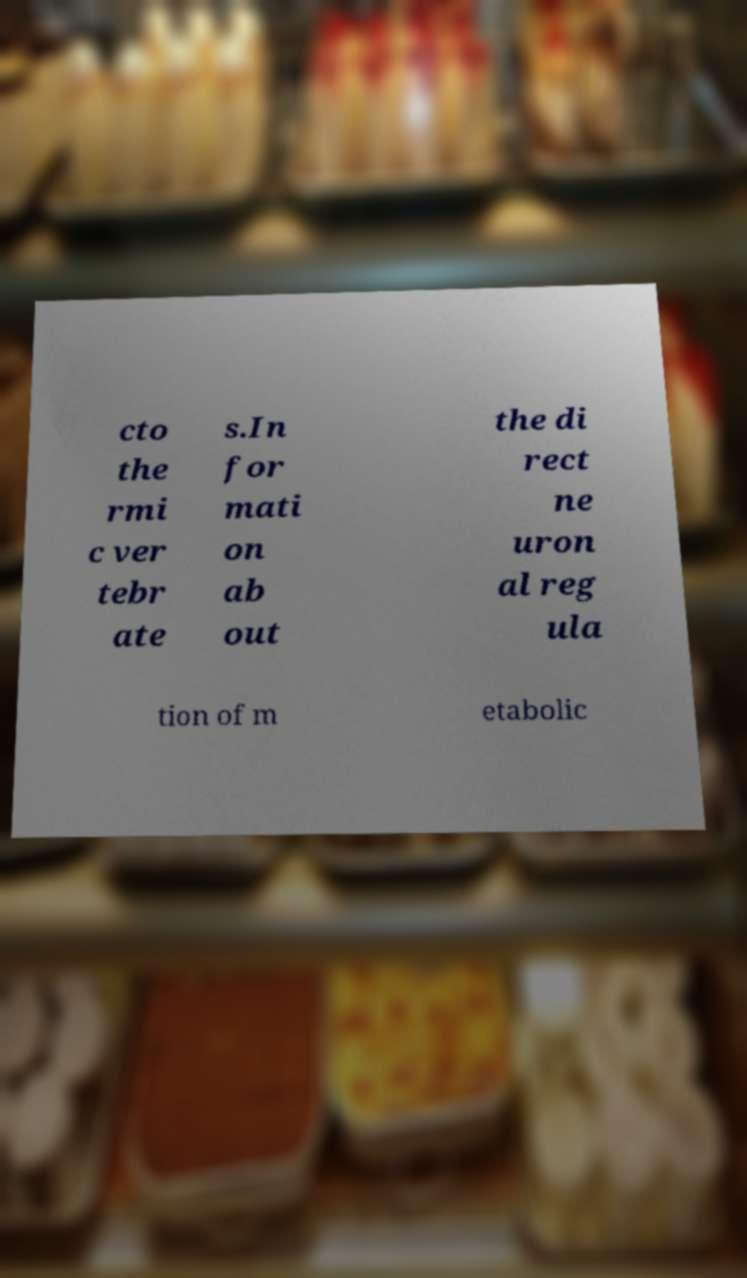Could you assist in decoding the text presented in this image and type it out clearly? cto the rmi c ver tebr ate s.In for mati on ab out the di rect ne uron al reg ula tion of m etabolic 